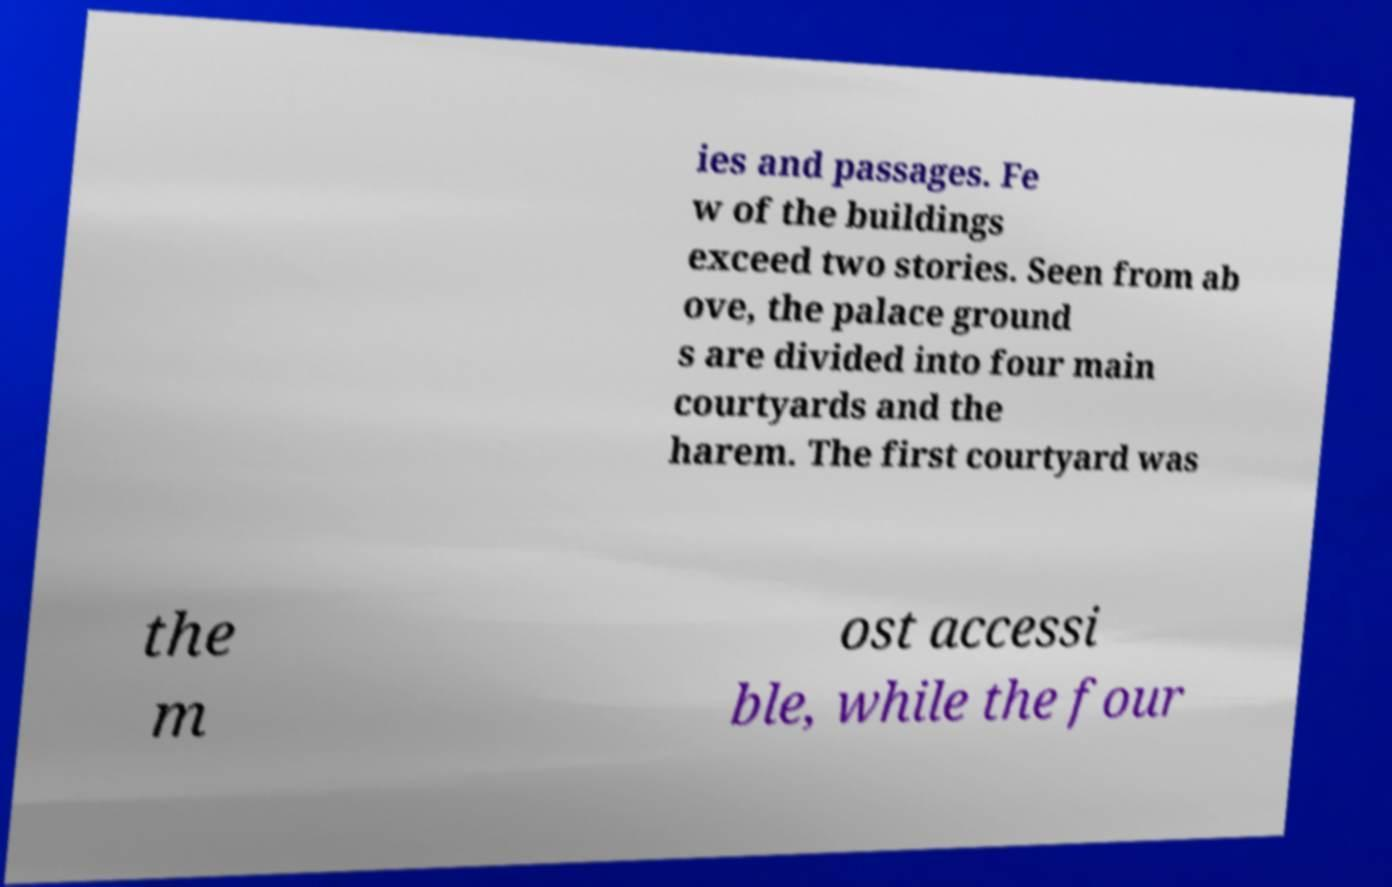Can you accurately transcribe the text from the provided image for me? ies and passages. Fe w of the buildings exceed two stories. Seen from ab ove, the palace ground s are divided into four main courtyards and the harem. The first courtyard was the m ost accessi ble, while the four 